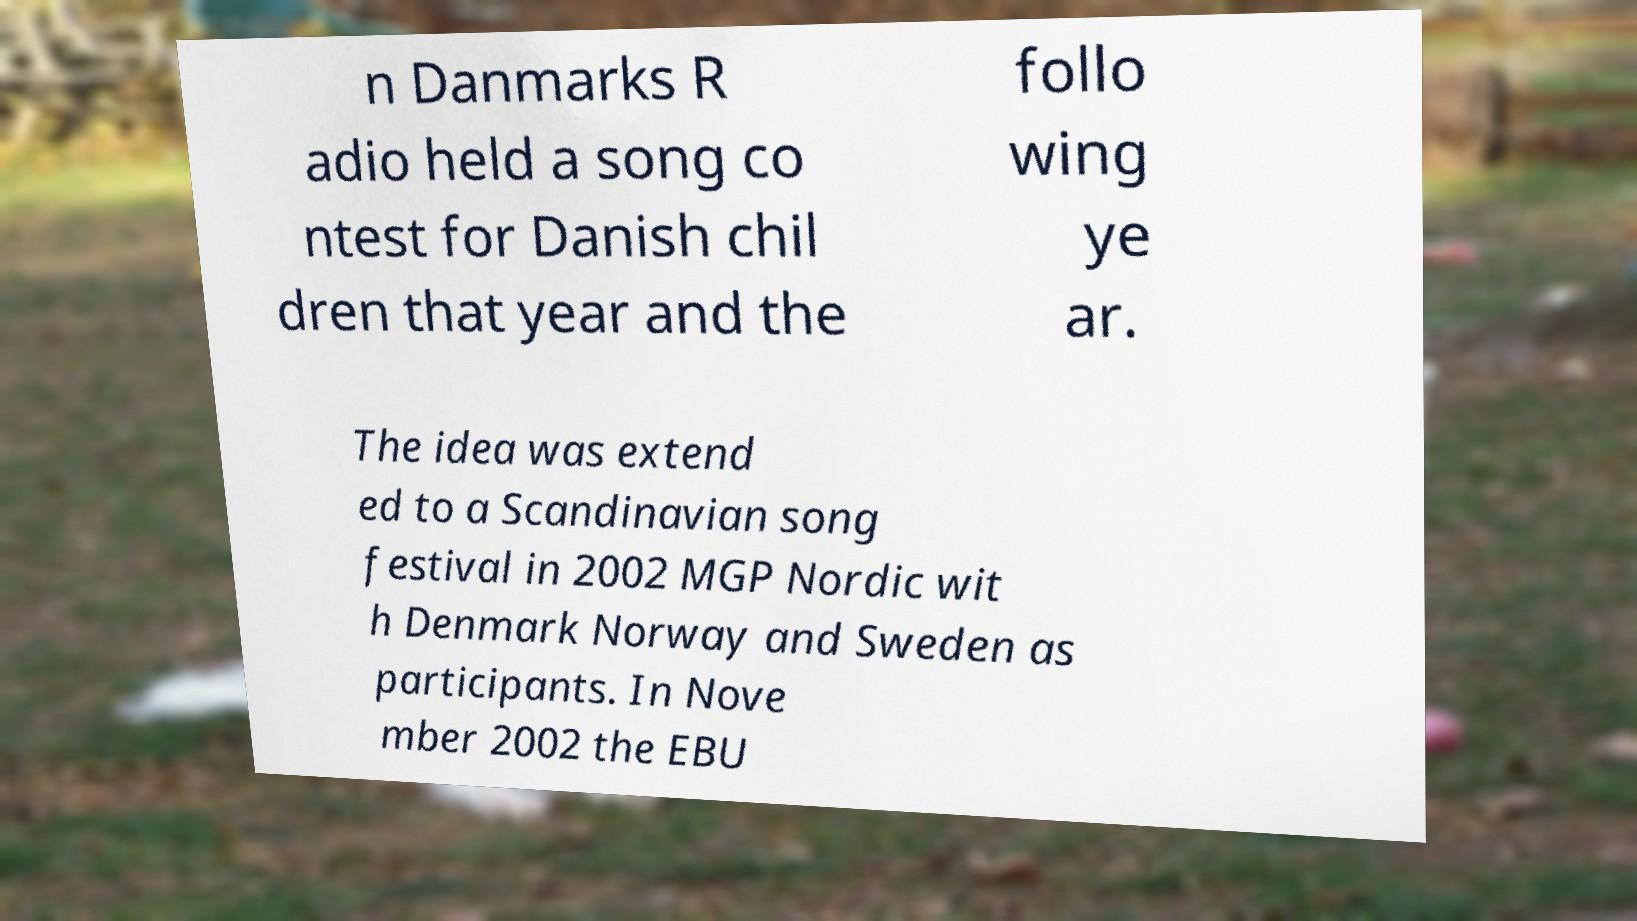There's text embedded in this image that I need extracted. Can you transcribe it verbatim? n Danmarks R adio held a song co ntest for Danish chil dren that year and the follo wing ye ar. The idea was extend ed to a Scandinavian song festival in 2002 MGP Nordic wit h Denmark Norway and Sweden as participants. In Nove mber 2002 the EBU 